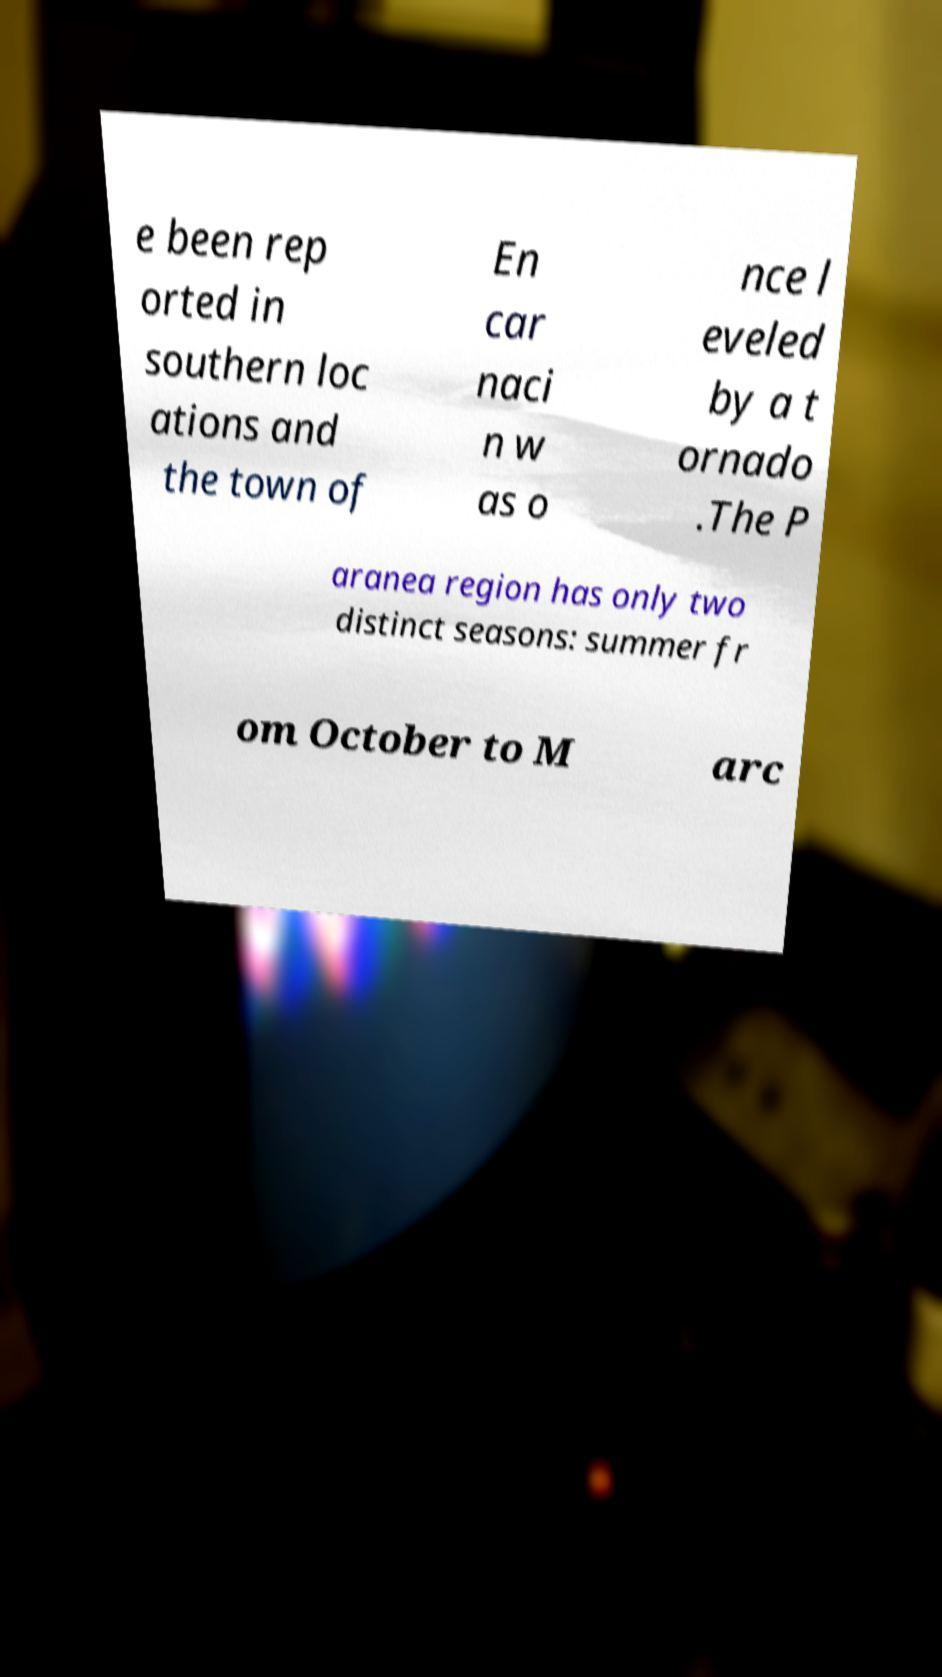Please identify and transcribe the text found in this image. e been rep orted in southern loc ations and the town of En car naci n w as o nce l eveled by a t ornado .The P aranea region has only two distinct seasons: summer fr om October to M arc 